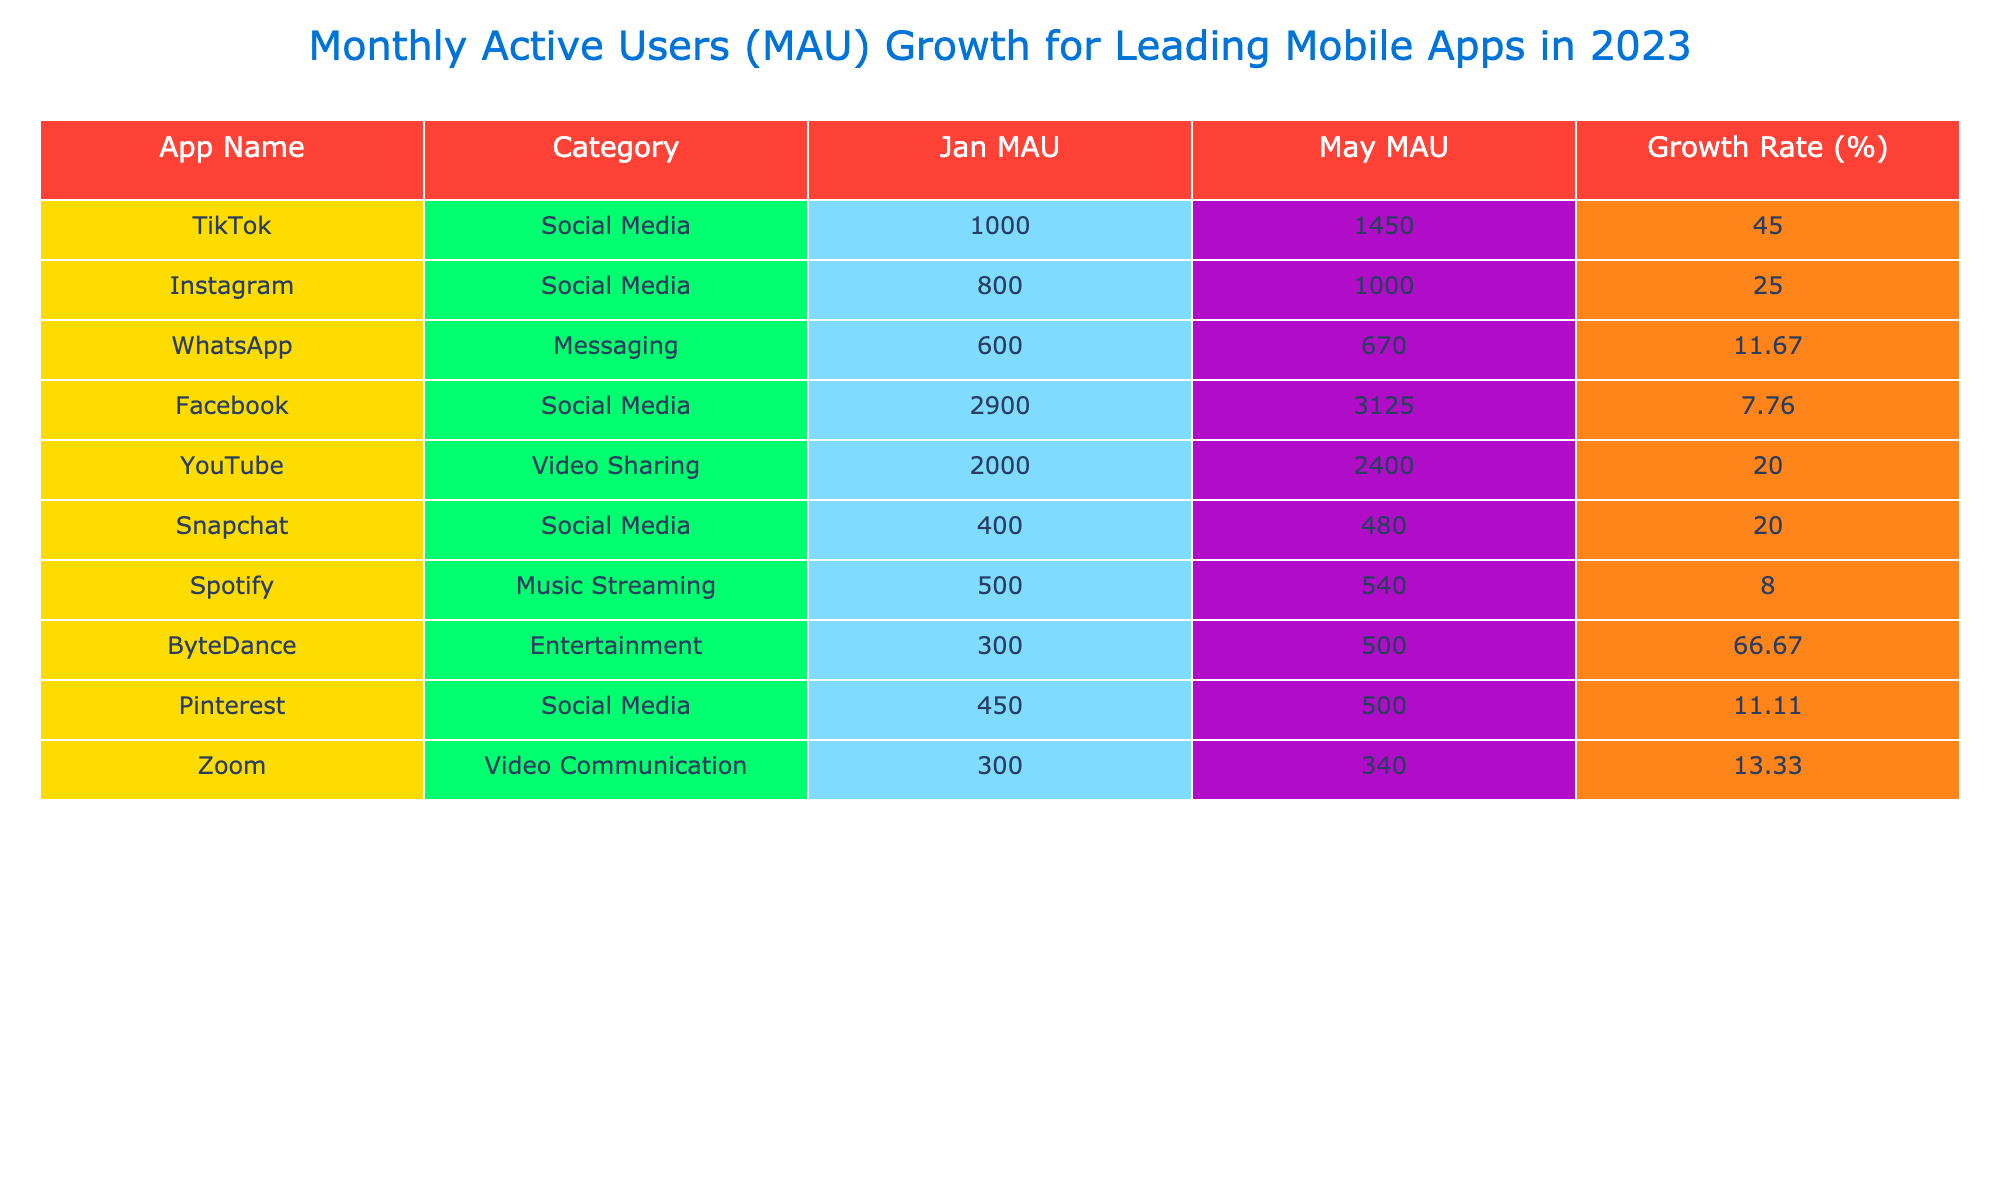What is the Growth Rate for TikTok? To find the Growth Rate for TikTok, we look at the values for January and May MAU. January has 1000 million and May has 1450 million. The growth rate is calculated as (1450 - 1000) / 1000 * 100 = 45%.
Answer: 45% Which app had the highest January MAU? Looking at the January MAU, Facebook has the highest value with 2900 million users compared to other apps listed.
Answer: Facebook What is the average MAU in May for all the apps? To find the average MAU in May, we sum the May values: (1450 + 1000 + 670 + 3125 + 2400 + 480 + 540 + 500 + 500 + 340) = 10795. We then divide this sum by the total number of apps (10), which gives us an average of 1079.5 million.
Answer: 1079.5 Did WhatsApp have a higher MAU in January than Spotify? In January, WhatsApp had 600 million MAU, while Spotify had 500 million MAU. Since 600 is greater than 500, the answer is yes.
Answer: Yes Which app experienced the least growth percentage from January to May? Calculate the growth for each app and identify the minimum: TikTok (45%), Instagram (25%), WhatsApp (11.67%), Facebook (7.76%), YouTube (20%), Snapchat (20%), Spotify (8%), ByteDance (66.67%), Pinterest (11.11%), Zoom (13.33%). The least growth rate is for Facebook at 7.76%.
Answer: Facebook What is the total MAU increase from January to May for all apps combined? To calculate the total increase, find the sum of May MAU and subtract the sum of January MAU: (1450 + 1000 + 670 + 3125 + 2400 + 480 + 540 + 500 + 500 + 340) - (1000 + 800 + 600 + 2900 + 2000 + 400 + 500 + 300 + 450 + 300) = 10795 - 11950 = -1155, meaning a decrease overall.
Answer: -1155 Which app had the greatest MAU increase from January to May? Calculate the increase for each app: TikTok (450), Instagram (200), WhatsApp (70), Facebook (225), YouTube (400), Snapchat (80), Spotify (40), ByteDance (200), Pinterest (50), Zoom (40). The highest increase is for TikTok with an increase of 450 million users.
Answer: TikTok Is the MAU in February for YouTube greater than the MAU in March for Snapchat? Comparing the values, YouTube in February had 2100 million, while Snapchat in March had 440 million. Since 2100 is greater than 440, the answer is yes.
Answer: Yes What percentage of increase in MAU did ByteDance experience over the five months? To calculate the percentage increase for ByteDance, we look at the starting MAU in January (300) and the MAU in May (500). The growth is (500 - 300) / 300 * 100 = 66.67%.
Answer: 66.67% 